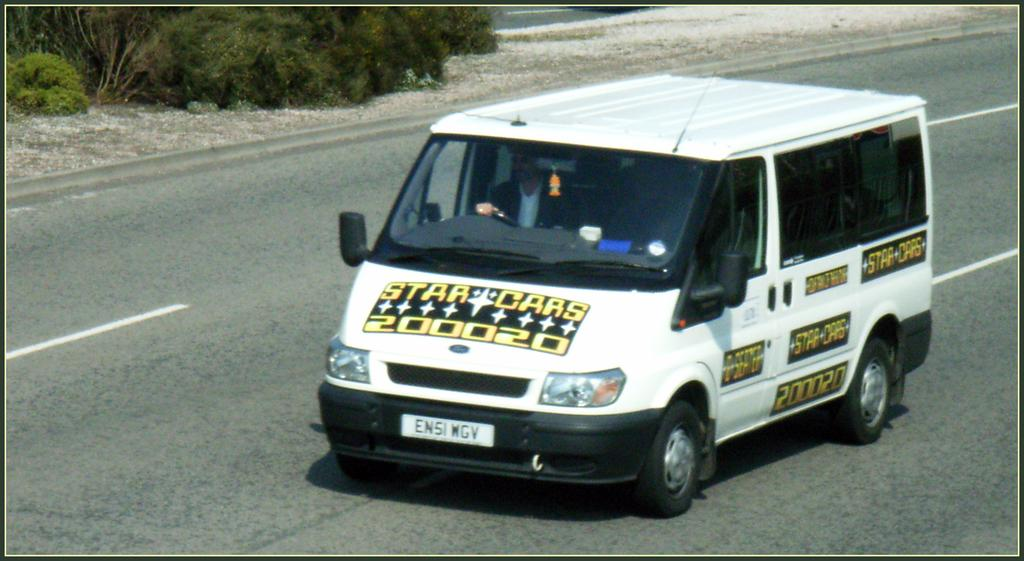What is happening in the image? There is a person inside a vehicle in the image. Where is the vehicle located? The vehicle is on the road. What can be seen in the top left corner of the image? There are plants in the top left corner of the image. What type of pear is hanging from the plants in the top left corner of the image? There is no pear present in the image; only plants are visible in the top left corner. 